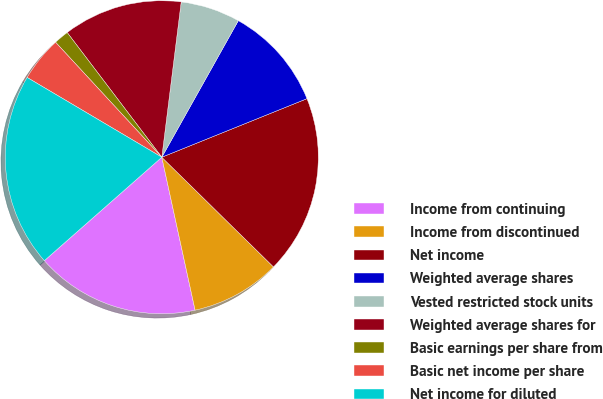Convert chart to OTSL. <chart><loc_0><loc_0><loc_500><loc_500><pie_chart><fcel>Income from continuing<fcel>Income from discontinued<fcel>Net income<fcel>Weighted average shares<fcel>Vested restricted stock units<fcel>Weighted average shares for<fcel>Basic earnings per share from<fcel>Basic net income per share<fcel>Net income for diluted<nl><fcel>16.92%<fcel>9.23%<fcel>18.46%<fcel>10.77%<fcel>6.15%<fcel>12.31%<fcel>1.54%<fcel>4.62%<fcel>20.0%<nl></chart> 